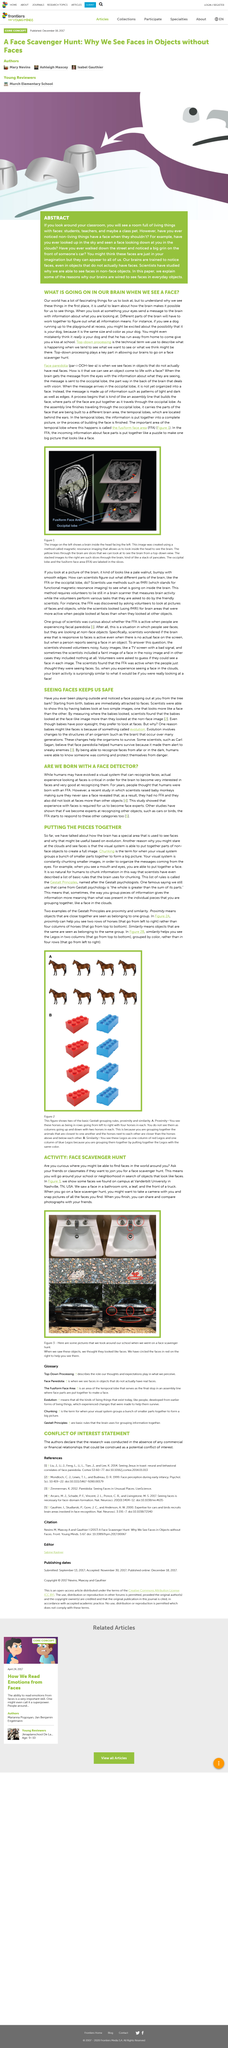Identify some key points in this picture. A face scavenger hunt is an activity where individuals search for objects in their environment that resemble faces. Participants may explore their school or neighborhood to find these faces, and the objective is to find as many examples as possible within a specified time frame. This activity encourages observation, creativity, and teamwork as participants work together to identify and document their findings. Scientists conducted an experiment to determine if animals have a face detector by raising baby monkeys and observing their behavior in response to faces. It is common for people to notice faces in non-living objects, as our brains are trained to recognize this pattern. After completing the face scavenger hunt, you have the option to share or compare the photographs taken with your friends, allowing for a fun and interactive way to showcase your photography skills and connect with others who enjoy the same activity. When we look at something, our eyes send a message to the brain with information about what we are seeing, and this triggers a process in the brain that allows us to recognize and interpret what we are looking at, including facial expressions. 